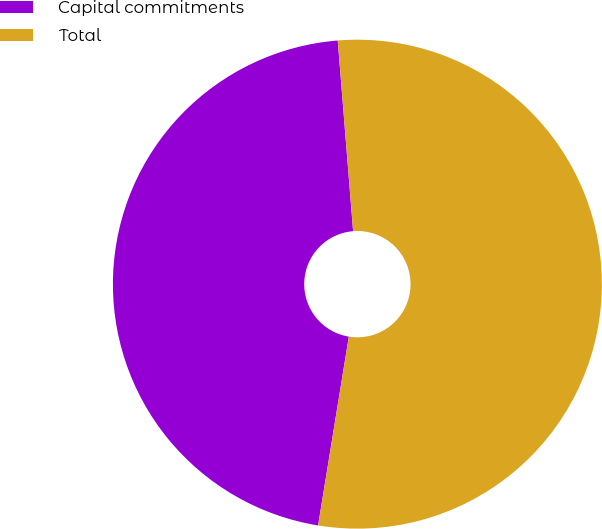Convert chart. <chart><loc_0><loc_0><loc_500><loc_500><pie_chart><fcel>Capital commitments<fcel>Total<nl><fcel>46.15%<fcel>53.85%<nl></chart> 